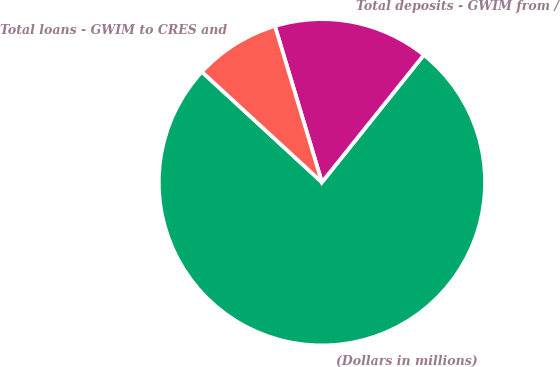Convert chart. <chart><loc_0><loc_0><loc_500><loc_500><pie_chart><fcel>(Dollars in millions)<fcel>Total deposits - GWIM from /<fcel>Total loans - GWIM to CRES and<nl><fcel>76.1%<fcel>15.39%<fcel>8.51%<nl></chart> 